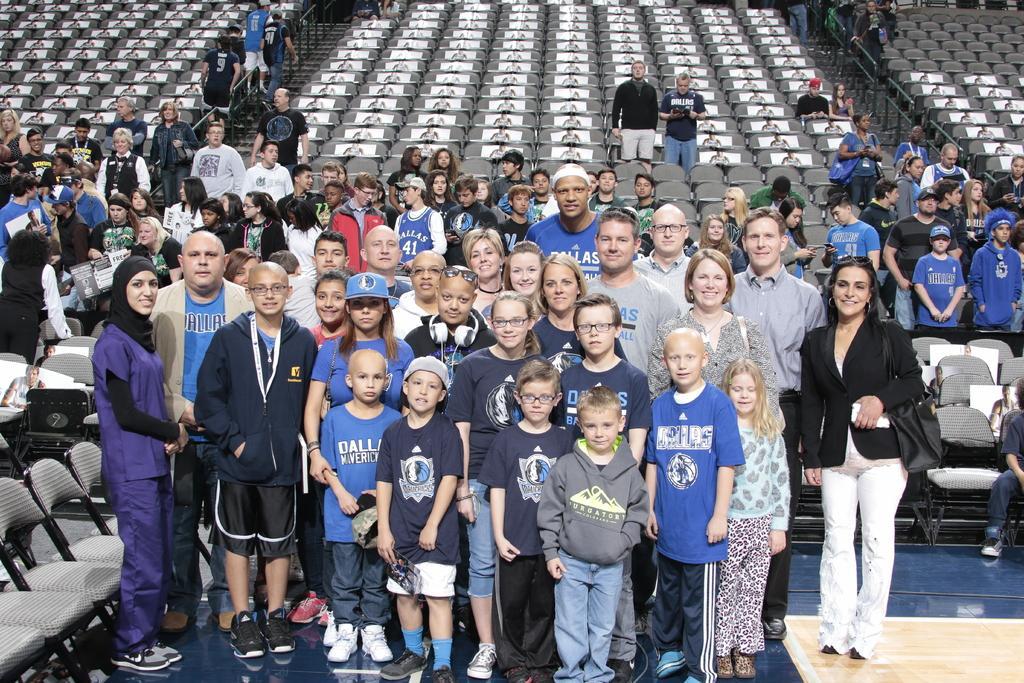Describe this image in one or two sentences. In the middle of the image few people are standing and smiling. Behind them there are some chairs. 